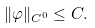<formula> <loc_0><loc_0><loc_500><loc_500>\| \varphi \| _ { C ^ { 0 } } \leq C .</formula> 